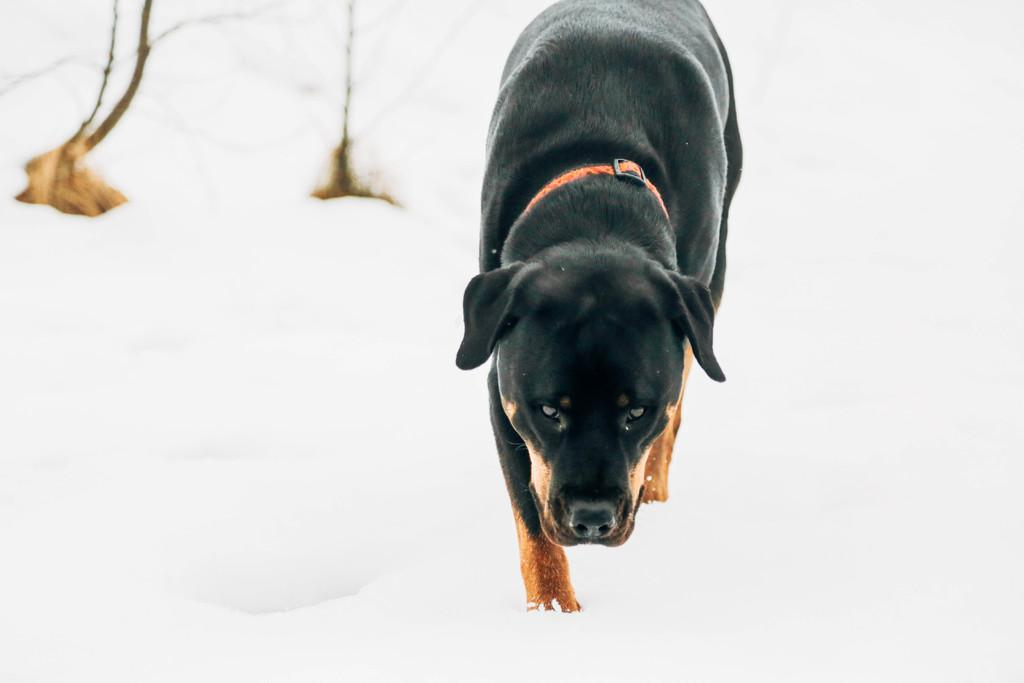What type of animal is in the image? There is a black dog in the image. What is the dog wearing? The dog is wearing a belt. Where is the dog located? The dog is on the snow. What language is the dog speaking in the image? A: Dogs do not speak human languages, so there is no language spoken by the dog in the image. 